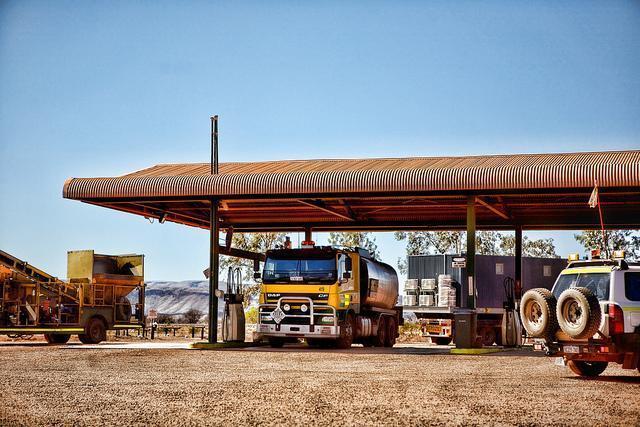How many yellow trucks?
Give a very brief answer. 1. How many trucks can you see?
Give a very brief answer. 3. How many people are riding a bike?
Give a very brief answer. 0. 